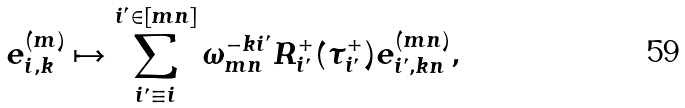<formula> <loc_0><loc_0><loc_500><loc_500>e ^ { ( m ) } _ { i , k } \mapsto \sum _ { i ^ { \prime } \equiv i } ^ { i ^ { \prime } \in [ m n ] } \omega _ { m n } ^ { - k i ^ { \prime } } R ^ { + } _ { i ^ { \prime } } ( \tau _ { i ^ { \prime } } ^ { + } ) e ^ { ( m n ) } _ { i ^ { \prime } , k n } ,</formula> 